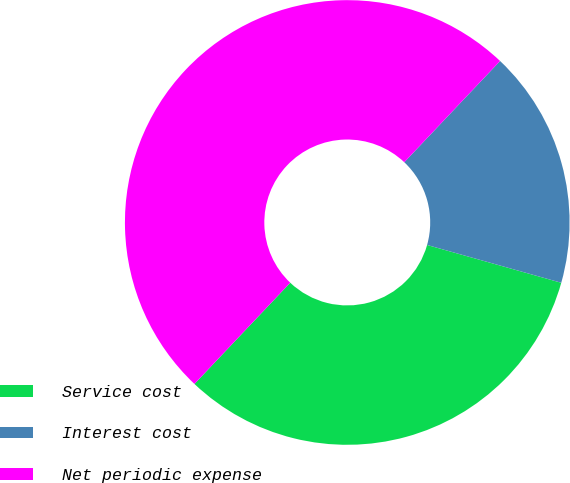Convert chart to OTSL. <chart><loc_0><loc_0><loc_500><loc_500><pie_chart><fcel>Service cost<fcel>Interest cost<fcel>Net periodic expense<nl><fcel>32.69%<fcel>17.31%<fcel>50.0%<nl></chart> 